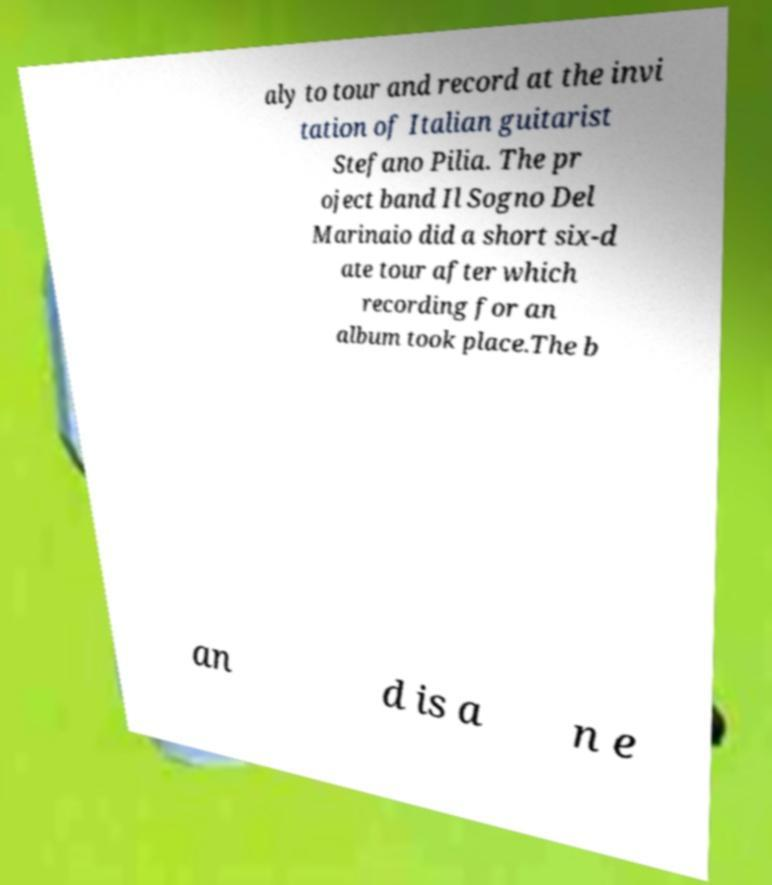I need the written content from this picture converted into text. Can you do that? aly to tour and record at the invi tation of Italian guitarist Stefano Pilia. The pr oject band Il Sogno Del Marinaio did a short six-d ate tour after which recording for an album took place.The b an d is a n e 